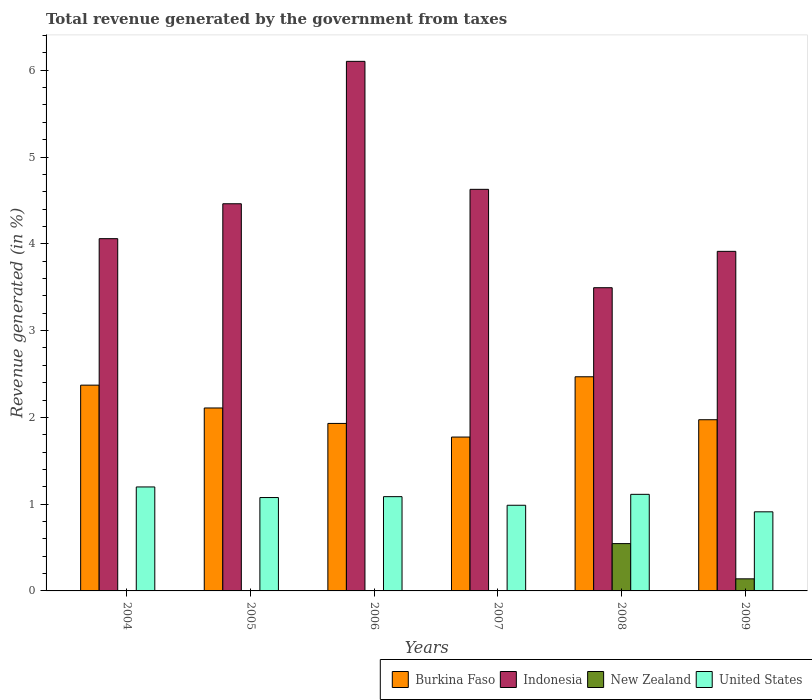How many groups of bars are there?
Your response must be concise. 6. Are the number of bars per tick equal to the number of legend labels?
Your answer should be very brief. Yes. How many bars are there on the 3rd tick from the left?
Offer a very short reply. 4. How many bars are there on the 2nd tick from the right?
Provide a succinct answer. 4. In how many cases, is the number of bars for a given year not equal to the number of legend labels?
Give a very brief answer. 0. What is the total revenue generated in United States in 2007?
Your response must be concise. 0.99. Across all years, what is the maximum total revenue generated in United States?
Make the answer very short. 1.2. Across all years, what is the minimum total revenue generated in Burkina Faso?
Offer a terse response. 1.77. In which year was the total revenue generated in Indonesia maximum?
Keep it short and to the point. 2006. In which year was the total revenue generated in Indonesia minimum?
Provide a short and direct response. 2008. What is the total total revenue generated in New Zealand in the graph?
Provide a short and direct response. 0.7. What is the difference between the total revenue generated in Indonesia in 2004 and that in 2005?
Your answer should be very brief. -0.4. What is the difference between the total revenue generated in United States in 2007 and the total revenue generated in Indonesia in 2006?
Offer a very short reply. -5.12. What is the average total revenue generated in New Zealand per year?
Make the answer very short. 0.12. In the year 2006, what is the difference between the total revenue generated in Burkina Faso and total revenue generated in New Zealand?
Offer a very short reply. 1.93. What is the ratio of the total revenue generated in United States in 2004 to that in 2006?
Make the answer very short. 1.1. Is the total revenue generated in Indonesia in 2004 less than that in 2008?
Offer a terse response. No. Is the difference between the total revenue generated in Burkina Faso in 2004 and 2006 greater than the difference between the total revenue generated in New Zealand in 2004 and 2006?
Make the answer very short. Yes. What is the difference between the highest and the second highest total revenue generated in Indonesia?
Make the answer very short. 1.47. What is the difference between the highest and the lowest total revenue generated in New Zealand?
Your response must be concise. 0.54. What does the 2nd bar from the right in 2008 represents?
Provide a succinct answer. New Zealand. Is it the case that in every year, the sum of the total revenue generated in Burkina Faso and total revenue generated in Indonesia is greater than the total revenue generated in New Zealand?
Offer a terse response. Yes. How many bars are there?
Offer a very short reply. 24. Are all the bars in the graph horizontal?
Make the answer very short. No. How many years are there in the graph?
Give a very brief answer. 6. What is the difference between two consecutive major ticks on the Y-axis?
Ensure brevity in your answer.  1. Does the graph contain any zero values?
Make the answer very short. No. How are the legend labels stacked?
Your response must be concise. Horizontal. What is the title of the graph?
Provide a succinct answer. Total revenue generated by the government from taxes. Does "Serbia" appear as one of the legend labels in the graph?
Give a very brief answer. No. What is the label or title of the Y-axis?
Your answer should be very brief. Revenue generated (in %). What is the Revenue generated (in %) in Burkina Faso in 2004?
Provide a short and direct response. 2.37. What is the Revenue generated (in %) in Indonesia in 2004?
Your answer should be very brief. 4.06. What is the Revenue generated (in %) of New Zealand in 2004?
Provide a short and direct response. 0. What is the Revenue generated (in %) of United States in 2004?
Keep it short and to the point. 1.2. What is the Revenue generated (in %) in Burkina Faso in 2005?
Make the answer very short. 2.11. What is the Revenue generated (in %) in Indonesia in 2005?
Offer a terse response. 4.46. What is the Revenue generated (in %) in New Zealand in 2005?
Make the answer very short. 0. What is the Revenue generated (in %) in United States in 2005?
Give a very brief answer. 1.08. What is the Revenue generated (in %) of Burkina Faso in 2006?
Make the answer very short. 1.93. What is the Revenue generated (in %) of Indonesia in 2006?
Offer a terse response. 6.1. What is the Revenue generated (in %) of New Zealand in 2006?
Offer a very short reply. 0. What is the Revenue generated (in %) in United States in 2006?
Provide a succinct answer. 1.09. What is the Revenue generated (in %) in Burkina Faso in 2007?
Provide a succinct answer. 1.77. What is the Revenue generated (in %) of Indonesia in 2007?
Provide a succinct answer. 4.63. What is the Revenue generated (in %) of New Zealand in 2007?
Keep it short and to the point. 0. What is the Revenue generated (in %) of United States in 2007?
Your answer should be compact. 0.99. What is the Revenue generated (in %) in Burkina Faso in 2008?
Your response must be concise. 2.47. What is the Revenue generated (in %) of Indonesia in 2008?
Provide a short and direct response. 3.49. What is the Revenue generated (in %) of New Zealand in 2008?
Ensure brevity in your answer.  0.55. What is the Revenue generated (in %) in United States in 2008?
Provide a succinct answer. 1.11. What is the Revenue generated (in %) in Burkina Faso in 2009?
Ensure brevity in your answer.  1.97. What is the Revenue generated (in %) in Indonesia in 2009?
Provide a short and direct response. 3.91. What is the Revenue generated (in %) in New Zealand in 2009?
Keep it short and to the point. 0.14. What is the Revenue generated (in %) in United States in 2009?
Offer a very short reply. 0.91. Across all years, what is the maximum Revenue generated (in %) of Burkina Faso?
Your response must be concise. 2.47. Across all years, what is the maximum Revenue generated (in %) in Indonesia?
Your answer should be compact. 6.1. Across all years, what is the maximum Revenue generated (in %) of New Zealand?
Provide a succinct answer. 0.55. Across all years, what is the maximum Revenue generated (in %) in United States?
Provide a succinct answer. 1.2. Across all years, what is the minimum Revenue generated (in %) of Burkina Faso?
Keep it short and to the point. 1.77. Across all years, what is the minimum Revenue generated (in %) of Indonesia?
Your answer should be compact. 3.49. Across all years, what is the minimum Revenue generated (in %) in New Zealand?
Your answer should be very brief. 0. Across all years, what is the minimum Revenue generated (in %) of United States?
Your answer should be compact. 0.91. What is the total Revenue generated (in %) in Burkina Faso in the graph?
Offer a very short reply. 12.62. What is the total Revenue generated (in %) of Indonesia in the graph?
Make the answer very short. 26.66. What is the total Revenue generated (in %) of New Zealand in the graph?
Offer a terse response. 0.7. What is the total Revenue generated (in %) in United States in the graph?
Make the answer very short. 6.37. What is the difference between the Revenue generated (in %) in Burkina Faso in 2004 and that in 2005?
Your response must be concise. 0.26. What is the difference between the Revenue generated (in %) of Indonesia in 2004 and that in 2005?
Provide a short and direct response. -0.4. What is the difference between the Revenue generated (in %) in New Zealand in 2004 and that in 2005?
Your answer should be very brief. 0. What is the difference between the Revenue generated (in %) of United States in 2004 and that in 2005?
Provide a succinct answer. 0.12. What is the difference between the Revenue generated (in %) in Burkina Faso in 2004 and that in 2006?
Your answer should be compact. 0.44. What is the difference between the Revenue generated (in %) in Indonesia in 2004 and that in 2006?
Provide a short and direct response. -2.04. What is the difference between the Revenue generated (in %) of New Zealand in 2004 and that in 2006?
Provide a short and direct response. -0. What is the difference between the Revenue generated (in %) of United States in 2004 and that in 2006?
Provide a short and direct response. 0.11. What is the difference between the Revenue generated (in %) of Burkina Faso in 2004 and that in 2007?
Provide a succinct answer. 0.6. What is the difference between the Revenue generated (in %) of Indonesia in 2004 and that in 2007?
Give a very brief answer. -0.57. What is the difference between the Revenue generated (in %) of New Zealand in 2004 and that in 2007?
Your response must be concise. 0. What is the difference between the Revenue generated (in %) of United States in 2004 and that in 2007?
Give a very brief answer. 0.21. What is the difference between the Revenue generated (in %) of Burkina Faso in 2004 and that in 2008?
Your response must be concise. -0.1. What is the difference between the Revenue generated (in %) of Indonesia in 2004 and that in 2008?
Your answer should be very brief. 0.57. What is the difference between the Revenue generated (in %) in New Zealand in 2004 and that in 2008?
Your answer should be very brief. -0.54. What is the difference between the Revenue generated (in %) of United States in 2004 and that in 2008?
Offer a terse response. 0.09. What is the difference between the Revenue generated (in %) of Burkina Faso in 2004 and that in 2009?
Provide a succinct answer. 0.4. What is the difference between the Revenue generated (in %) of Indonesia in 2004 and that in 2009?
Ensure brevity in your answer.  0.15. What is the difference between the Revenue generated (in %) in New Zealand in 2004 and that in 2009?
Provide a succinct answer. -0.13. What is the difference between the Revenue generated (in %) in United States in 2004 and that in 2009?
Give a very brief answer. 0.29. What is the difference between the Revenue generated (in %) of Burkina Faso in 2005 and that in 2006?
Provide a succinct answer. 0.18. What is the difference between the Revenue generated (in %) in Indonesia in 2005 and that in 2006?
Provide a short and direct response. -1.64. What is the difference between the Revenue generated (in %) of New Zealand in 2005 and that in 2006?
Offer a very short reply. -0. What is the difference between the Revenue generated (in %) in United States in 2005 and that in 2006?
Your answer should be compact. -0.01. What is the difference between the Revenue generated (in %) of Burkina Faso in 2005 and that in 2007?
Ensure brevity in your answer.  0.34. What is the difference between the Revenue generated (in %) of Indonesia in 2005 and that in 2007?
Keep it short and to the point. -0.17. What is the difference between the Revenue generated (in %) in New Zealand in 2005 and that in 2007?
Offer a terse response. 0. What is the difference between the Revenue generated (in %) of United States in 2005 and that in 2007?
Your answer should be compact. 0.09. What is the difference between the Revenue generated (in %) in Burkina Faso in 2005 and that in 2008?
Offer a very short reply. -0.36. What is the difference between the Revenue generated (in %) in Indonesia in 2005 and that in 2008?
Your answer should be compact. 0.97. What is the difference between the Revenue generated (in %) of New Zealand in 2005 and that in 2008?
Your answer should be very brief. -0.54. What is the difference between the Revenue generated (in %) in United States in 2005 and that in 2008?
Offer a very short reply. -0.04. What is the difference between the Revenue generated (in %) of Burkina Faso in 2005 and that in 2009?
Provide a succinct answer. 0.14. What is the difference between the Revenue generated (in %) of Indonesia in 2005 and that in 2009?
Offer a terse response. 0.55. What is the difference between the Revenue generated (in %) of New Zealand in 2005 and that in 2009?
Your answer should be compact. -0.14. What is the difference between the Revenue generated (in %) in United States in 2005 and that in 2009?
Provide a short and direct response. 0.16. What is the difference between the Revenue generated (in %) in Burkina Faso in 2006 and that in 2007?
Offer a terse response. 0.16. What is the difference between the Revenue generated (in %) of Indonesia in 2006 and that in 2007?
Your answer should be compact. 1.47. What is the difference between the Revenue generated (in %) in New Zealand in 2006 and that in 2007?
Offer a terse response. 0. What is the difference between the Revenue generated (in %) of United States in 2006 and that in 2007?
Offer a very short reply. 0.1. What is the difference between the Revenue generated (in %) in Burkina Faso in 2006 and that in 2008?
Ensure brevity in your answer.  -0.54. What is the difference between the Revenue generated (in %) in Indonesia in 2006 and that in 2008?
Make the answer very short. 2.61. What is the difference between the Revenue generated (in %) in New Zealand in 2006 and that in 2008?
Your response must be concise. -0.54. What is the difference between the Revenue generated (in %) of United States in 2006 and that in 2008?
Ensure brevity in your answer.  -0.03. What is the difference between the Revenue generated (in %) of Burkina Faso in 2006 and that in 2009?
Your response must be concise. -0.04. What is the difference between the Revenue generated (in %) in Indonesia in 2006 and that in 2009?
Your response must be concise. 2.19. What is the difference between the Revenue generated (in %) of New Zealand in 2006 and that in 2009?
Your answer should be very brief. -0.13. What is the difference between the Revenue generated (in %) of United States in 2006 and that in 2009?
Ensure brevity in your answer.  0.17. What is the difference between the Revenue generated (in %) in Burkina Faso in 2007 and that in 2008?
Offer a terse response. -0.69. What is the difference between the Revenue generated (in %) in Indonesia in 2007 and that in 2008?
Keep it short and to the point. 1.13. What is the difference between the Revenue generated (in %) of New Zealand in 2007 and that in 2008?
Offer a very short reply. -0.54. What is the difference between the Revenue generated (in %) in United States in 2007 and that in 2008?
Your answer should be very brief. -0.13. What is the difference between the Revenue generated (in %) in Burkina Faso in 2007 and that in 2009?
Keep it short and to the point. -0.2. What is the difference between the Revenue generated (in %) in Indonesia in 2007 and that in 2009?
Your answer should be very brief. 0.71. What is the difference between the Revenue generated (in %) of New Zealand in 2007 and that in 2009?
Ensure brevity in your answer.  -0.14. What is the difference between the Revenue generated (in %) in United States in 2007 and that in 2009?
Offer a terse response. 0.08. What is the difference between the Revenue generated (in %) in Burkina Faso in 2008 and that in 2009?
Your answer should be very brief. 0.49. What is the difference between the Revenue generated (in %) in Indonesia in 2008 and that in 2009?
Your answer should be compact. -0.42. What is the difference between the Revenue generated (in %) of New Zealand in 2008 and that in 2009?
Provide a succinct answer. 0.41. What is the difference between the Revenue generated (in %) of United States in 2008 and that in 2009?
Ensure brevity in your answer.  0.2. What is the difference between the Revenue generated (in %) in Burkina Faso in 2004 and the Revenue generated (in %) in Indonesia in 2005?
Give a very brief answer. -2.09. What is the difference between the Revenue generated (in %) in Burkina Faso in 2004 and the Revenue generated (in %) in New Zealand in 2005?
Your answer should be compact. 2.37. What is the difference between the Revenue generated (in %) of Burkina Faso in 2004 and the Revenue generated (in %) of United States in 2005?
Your response must be concise. 1.29. What is the difference between the Revenue generated (in %) of Indonesia in 2004 and the Revenue generated (in %) of New Zealand in 2005?
Ensure brevity in your answer.  4.06. What is the difference between the Revenue generated (in %) of Indonesia in 2004 and the Revenue generated (in %) of United States in 2005?
Ensure brevity in your answer.  2.98. What is the difference between the Revenue generated (in %) of New Zealand in 2004 and the Revenue generated (in %) of United States in 2005?
Your response must be concise. -1.07. What is the difference between the Revenue generated (in %) of Burkina Faso in 2004 and the Revenue generated (in %) of Indonesia in 2006?
Provide a succinct answer. -3.73. What is the difference between the Revenue generated (in %) in Burkina Faso in 2004 and the Revenue generated (in %) in New Zealand in 2006?
Make the answer very short. 2.37. What is the difference between the Revenue generated (in %) in Burkina Faso in 2004 and the Revenue generated (in %) in United States in 2006?
Offer a terse response. 1.28. What is the difference between the Revenue generated (in %) of Indonesia in 2004 and the Revenue generated (in %) of New Zealand in 2006?
Your answer should be very brief. 4.05. What is the difference between the Revenue generated (in %) of Indonesia in 2004 and the Revenue generated (in %) of United States in 2006?
Your answer should be compact. 2.97. What is the difference between the Revenue generated (in %) of New Zealand in 2004 and the Revenue generated (in %) of United States in 2006?
Offer a terse response. -1.08. What is the difference between the Revenue generated (in %) in Burkina Faso in 2004 and the Revenue generated (in %) in Indonesia in 2007?
Provide a succinct answer. -2.26. What is the difference between the Revenue generated (in %) of Burkina Faso in 2004 and the Revenue generated (in %) of New Zealand in 2007?
Ensure brevity in your answer.  2.37. What is the difference between the Revenue generated (in %) of Burkina Faso in 2004 and the Revenue generated (in %) of United States in 2007?
Provide a short and direct response. 1.38. What is the difference between the Revenue generated (in %) of Indonesia in 2004 and the Revenue generated (in %) of New Zealand in 2007?
Provide a short and direct response. 4.06. What is the difference between the Revenue generated (in %) of Indonesia in 2004 and the Revenue generated (in %) of United States in 2007?
Offer a very short reply. 3.07. What is the difference between the Revenue generated (in %) in New Zealand in 2004 and the Revenue generated (in %) in United States in 2007?
Provide a succinct answer. -0.98. What is the difference between the Revenue generated (in %) in Burkina Faso in 2004 and the Revenue generated (in %) in Indonesia in 2008?
Your answer should be compact. -1.12. What is the difference between the Revenue generated (in %) of Burkina Faso in 2004 and the Revenue generated (in %) of New Zealand in 2008?
Offer a very short reply. 1.83. What is the difference between the Revenue generated (in %) of Burkina Faso in 2004 and the Revenue generated (in %) of United States in 2008?
Make the answer very short. 1.26. What is the difference between the Revenue generated (in %) of Indonesia in 2004 and the Revenue generated (in %) of New Zealand in 2008?
Your response must be concise. 3.51. What is the difference between the Revenue generated (in %) in Indonesia in 2004 and the Revenue generated (in %) in United States in 2008?
Ensure brevity in your answer.  2.95. What is the difference between the Revenue generated (in %) of New Zealand in 2004 and the Revenue generated (in %) of United States in 2008?
Offer a terse response. -1.11. What is the difference between the Revenue generated (in %) in Burkina Faso in 2004 and the Revenue generated (in %) in Indonesia in 2009?
Give a very brief answer. -1.54. What is the difference between the Revenue generated (in %) in Burkina Faso in 2004 and the Revenue generated (in %) in New Zealand in 2009?
Provide a short and direct response. 2.23. What is the difference between the Revenue generated (in %) of Burkina Faso in 2004 and the Revenue generated (in %) of United States in 2009?
Offer a terse response. 1.46. What is the difference between the Revenue generated (in %) in Indonesia in 2004 and the Revenue generated (in %) in New Zealand in 2009?
Provide a succinct answer. 3.92. What is the difference between the Revenue generated (in %) in Indonesia in 2004 and the Revenue generated (in %) in United States in 2009?
Ensure brevity in your answer.  3.15. What is the difference between the Revenue generated (in %) of New Zealand in 2004 and the Revenue generated (in %) of United States in 2009?
Your response must be concise. -0.91. What is the difference between the Revenue generated (in %) in Burkina Faso in 2005 and the Revenue generated (in %) in Indonesia in 2006?
Provide a short and direct response. -3.99. What is the difference between the Revenue generated (in %) of Burkina Faso in 2005 and the Revenue generated (in %) of New Zealand in 2006?
Your answer should be very brief. 2.1. What is the difference between the Revenue generated (in %) in Burkina Faso in 2005 and the Revenue generated (in %) in United States in 2006?
Ensure brevity in your answer.  1.02. What is the difference between the Revenue generated (in %) in Indonesia in 2005 and the Revenue generated (in %) in New Zealand in 2006?
Your answer should be very brief. 4.46. What is the difference between the Revenue generated (in %) of Indonesia in 2005 and the Revenue generated (in %) of United States in 2006?
Keep it short and to the point. 3.38. What is the difference between the Revenue generated (in %) of New Zealand in 2005 and the Revenue generated (in %) of United States in 2006?
Offer a terse response. -1.08. What is the difference between the Revenue generated (in %) of Burkina Faso in 2005 and the Revenue generated (in %) of Indonesia in 2007?
Keep it short and to the point. -2.52. What is the difference between the Revenue generated (in %) in Burkina Faso in 2005 and the Revenue generated (in %) in New Zealand in 2007?
Provide a short and direct response. 2.11. What is the difference between the Revenue generated (in %) of Burkina Faso in 2005 and the Revenue generated (in %) of United States in 2007?
Offer a very short reply. 1.12. What is the difference between the Revenue generated (in %) of Indonesia in 2005 and the Revenue generated (in %) of New Zealand in 2007?
Keep it short and to the point. 4.46. What is the difference between the Revenue generated (in %) in Indonesia in 2005 and the Revenue generated (in %) in United States in 2007?
Provide a short and direct response. 3.47. What is the difference between the Revenue generated (in %) in New Zealand in 2005 and the Revenue generated (in %) in United States in 2007?
Provide a short and direct response. -0.98. What is the difference between the Revenue generated (in %) in Burkina Faso in 2005 and the Revenue generated (in %) in Indonesia in 2008?
Provide a succinct answer. -1.39. What is the difference between the Revenue generated (in %) in Burkina Faso in 2005 and the Revenue generated (in %) in New Zealand in 2008?
Your answer should be very brief. 1.56. What is the difference between the Revenue generated (in %) in Burkina Faso in 2005 and the Revenue generated (in %) in United States in 2008?
Your answer should be compact. 1. What is the difference between the Revenue generated (in %) in Indonesia in 2005 and the Revenue generated (in %) in New Zealand in 2008?
Offer a very short reply. 3.92. What is the difference between the Revenue generated (in %) in Indonesia in 2005 and the Revenue generated (in %) in United States in 2008?
Offer a terse response. 3.35. What is the difference between the Revenue generated (in %) of New Zealand in 2005 and the Revenue generated (in %) of United States in 2008?
Your answer should be compact. -1.11. What is the difference between the Revenue generated (in %) of Burkina Faso in 2005 and the Revenue generated (in %) of Indonesia in 2009?
Offer a terse response. -1.8. What is the difference between the Revenue generated (in %) of Burkina Faso in 2005 and the Revenue generated (in %) of New Zealand in 2009?
Make the answer very short. 1.97. What is the difference between the Revenue generated (in %) in Burkina Faso in 2005 and the Revenue generated (in %) in United States in 2009?
Offer a very short reply. 1.2. What is the difference between the Revenue generated (in %) in Indonesia in 2005 and the Revenue generated (in %) in New Zealand in 2009?
Keep it short and to the point. 4.32. What is the difference between the Revenue generated (in %) of Indonesia in 2005 and the Revenue generated (in %) of United States in 2009?
Provide a succinct answer. 3.55. What is the difference between the Revenue generated (in %) in New Zealand in 2005 and the Revenue generated (in %) in United States in 2009?
Provide a succinct answer. -0.91. What is the difference between the Revenue generated (in %) of Burkina Faso in 2006 and the Revenue generated (in %) of Indonesia in 2007?
Your response must be concise. -2.7. What is the difference between the Revenue generated (in %) in Burkina Faso in 2006 and the Revenue generated (in %) in New Zealand in 2007?
Make the answer very short. 1.93. What is the difference between the Revenue generated (in %) in Burkina Faso in 2006 and the Revenue generated (in %) in United States in 2007?
Give a very brief answer. 0.94. What is the difference between the Revenue generated (in %) in Indonesia in 2006 and the Revenue generated (in %) in New Zealand in 2007?
Offer a very short reply. 6.1. What is the difference between the Revenue generated (in %) in Indonesia in 2006 and the Revenue generated (in %) in United States in 2007?
Offer a very short reply. 5.12. What is the difference between the Revenue generated (in %) of New Zealand in 2006 and the Revenue generated (in %) of United States in 2007?
Give a very brief answer. -0.98. What is the difference between the Revenue generated (in %) of Burkina Faso in 2006 and the Revenue generated (in %) of Indonesia in 2008?
Offer a very short reply. -1.56. What is the difference between the Revenue generated (in %) in Burkina Faso in 2006 and the Revenue generated (in %) in New Zealand in 2008?
Your answer should be compact. 1.38. What is the difference between the Revenue generated (in %) in Burkina Faso in 2006 and the Revenue generated (in %) in United States in 2008?
Your answer should be very brief. 0.82. What is the difference between the Revenue generated (in %) of Indonesia in 2006 and the Revenue generated (in %) of New Zealand in 2008?
Provide a short and direct response. 5.56. What is the difference between the Revenue generated (in %) in Indonesia in 2006 and the Revenue generated (in %) in United States in 2008?
Offer a very short reply. 4.99. What is the difference between the Revenue generated (in %) in New Zealand in 2006 and the Revenue generated (in %) in United States in 2008?
Your answer should be compact. -1.11. What is the difference between the Revenue generated (in %) in Burkina Faso in 2006 and the Revenue generated (in %) in Indonesia in 2009?
Give a very brief answer. -1.98. What is the difference between the Revenue generated (in %) in Burkina Faso in 2006 and the Revenue generated (in %) in New Zealand in 2009?
Offer a terse response. 1.79. What is the difference between the Revenue generated (in %) of Burkina Faso in 2006 and the Revenue generated (in %) of United States in 2009?
Make the answer very short. 1.02. What is the difference between the Revenue generated (in %) in Indonesia in 2006 and the Revenue generated (in %) in New Zealand in 2009?
Provide a short and direct response. 5.96. What is the difference between the Revenue generated (in %) in Indonesia in 2006 and the Revenue generated (in %) in United States in 2009?
Your answer should be very brief. 5.19. What is the difference between the Revenue generated (in %) in New Zealand in 2006 and the Revenue generated (in %) in United States in 2009?
Keep it short and to the point. -0.91. What is the difference between the Revenue generated (in %) of Burkina Faso in 2007 and the Revenue generated (in %) of Indonesia in 2008?
Offer a very short reply. -1.72. What is the difference between the Revenue generated (in %) of Burkina Faso in 2007 and the Revenue generated (in %) of New Zealand in 2008?
Your response must be concise. 1.23. What is the difference between the Revenue generated (in %) of Burkina Faso in 2007 and the Revenue generated (in %) of United States in 2008?
Give a very brief answer. 0.66. What is the difference between the Revenue generated (in %) of Indonesia in 2007 and the Revenue generated (in %) of New Zealand in 2008?
Your response must be concise. 4.08. What is the difference between the Revenue generated (in %) in Indonesia in 2007 and the Revenue generated (in %) in United States in 2008?
Ensure brevity in your answer.  3.51. What is the difference between the Revenue generated (in %) of New Zealand in 2007 and the Revenue generated (in %) of United States in 2008?
Offer a very short reply. -1.11. What is the difference between the Revenue generated (in %) of Burkina Faso in 2007 and the Revenue generated (in %) of Indonesia in 2009?
Offer a terse response. -2.14. What is the difference between the Revenue generated (in %) in Burkina Faso in 2007 and the Revenue generated (in %) in New Zealand in 2009?
Ensure brevity in your answer.  1.63. What is the difference between the Revenue generated (in %) in Burkina Faso in 2007 and the Revenue generated (in %) in United States in 2009?
Provide a succinct answer. 0.86. What is the difference between the Revenue generated (in %) of Indonesia in 2007 and the Revenue generated (in %) of New Zealand in 2009?
Your response must be concise. 4.49. What is the difference between the Revenue generated (in %) of Indonesia in 2007 and the Revenue generated (in %) of United States in 2009?
Provide a short and direct response. 3.72. What is the difference between the Revenue generated (in %) of New Zealand in 2007 and the Revenue generated (in %) of United States in 2009?
Your response must be concise. -0.91. What is the difference between the Revenue generated (in %) in Burkina Faso in 2008 and the Revenue generated (in %) in Indonesia in 2009?
Offer a very short reply. -1.45. What is the difference between the Revenue generated (in %) in Burkina Faso in 2008 and the Revenue generated (in %) in New Zealand in 2009?
Your answer should be compact. 2.33. What is the difference between the Revenue generated (in %) in Burkina Faso in 2008 and the Revenue generated (in %) in United States in 2009?
Ensure brevity in your answer.  1.56. What is the difference between the Revenue generated (in %) in Indonesia in 2008 and the Revenue generated (in %) in New Zealand in 2009?
Offer a terse response. 3.35. What is the difference between the Revenue generated (in %) of Indonesia in 2008 and the Revenue generated (in %) of United States in 2009?
Provide a succinct answer. 2.58. What is the difference between the Revenue generated (in %) of New Zealand in 2008 and the Revenue generated (in %) of United States in 2009?
Your response must be concise. -0.37. What is the average Revenue generated (in %) in Burkina Faso per year?
Keep it short and to the point. 2.1. What is the average Revenue generated (in %) in Indonesia per year?
Make the answer very short. 4.44. What is the average Revenue generated (in %) of New Zealand per year?
Give a very brief answer. 0.12. What is the average Revenue generated (in %) of United States per year?
Your answer should be very brief. 1.06. In the year 2004, what is the difference between the Revenue generated (in %) in Burkina Faso and Revenue generated (in %) in Indonesia?
Provide a succinct answer. -1.69. In the year 2004, what is the difference between the Revenue generated (in %) in Burkina Faso and Revenue generated (in %) in New Zealand?
Provide a succinct answer. 2.37. In the year 2004, what is the difference between the Revenue generated (in %) of Burkina Faso and Revenue generated (in %) of United States?
Provide a short and direct response. 1.17. In the year 2004, what is the difference between the Revenue generated (in %) of Indonesia and Revenue generated (in %) of New Zealand?
Ensure brevity in your answer.  4.05. In the year 2004, what is the difference between the Revenue generated (in %) in Indonesia and Revenue generated (in %) in United States?
Keep it short and to the point. 2.86. In the year 2004, what is the difference between the Revenue generated (in %) in New Zealand and Revenue generated (in %) in United States?
Offer a terse response. -1.19. In the year 2005, what is the difference between the Revenue generated (in %) of Burkina Faso and Revenue generated (in %) of Indonesia?
Offer a terse response. -2.35. In the year 2005, what is the difference between the Revenue generated (in %) of Burkina Faso and Revenue generated (in %) of New Zealand?
Your response must be concise. 2.1. In the year 2005, what is the difference between the Revenue generated (in %) in Burkina Faso and Revenue generated (in %) in United States?
Your answer should be compact. 1.03. In the year 2005, what is the difference between the Revenue generated (in %) of Indonesia and Revenue generated (in %) of New Zealand?
Give a very brief answer. 4.46. In the year 2005, what is the difference between the Revenue generated (in %) of Indonesia and Revenue generated (in %) of United States?
Provide a short and direct response. 3.39. In the year 2005, what is the difference between the Revenue generated (in %) of New Zealand and Revenue generated (in %) of United States?
Your response must be concise. -1.07. In the year 2006, what is the difference between the Revenue generated (in %) of Burkina Faso and Revenue generated (in %) of Indonesia?
Give a very brief answer. -4.17. In the year 2006, what is the difference between the Revenue generated (in %) of Burkina Faso and Revenue generated (in %) of New Zealand?
Ensure brevity in your answer.  1.93. In the year 2006, what is the difference between the Revenue generated (in %) in Burkina Faso and Revenue generated (in %) in United States?
Keep it short and to the point. 0.84. In the year 2006, what is the difference between the Revenue generated (in %) in Indonesia and Revenue generated (in %) in New Zealand?
Ensure brevity in your answer.  6.1. In the year 2006, what is the difference between the Revenue generated (in %) of Indonesia and Revenue generated (in %) of United States?
Ensure brevity in your answer.  5.02. In the year 2006, what is the difference between the Revenue generated (in %) of New Zealand and Revenue generated (in %) of United States?
Provide a succinct answer. -1.08. In the year 2007, what is the difference between the Revenue generated (in %) in Burkina Faso and Revenue generated (in %) in Indonesia?
Offer a terse response. -2.85. In the year 2007, what is the difference between the Revenue generated (in %) in Burkina Faso and Revenue generated (in %) in New Zealand?
Give a very brief answer. 1.77. In the year 2007, what is the difference between the Revenue generated (in %) in Burkina Faso and Revenue generated (in %) in United States?
Provide a short and direct response. 0.79. In the year 2007, what is the difference between the Revenue generated (in %) of Indonesia and Revenue generated (in %) of New Zealand?
Give a very brief answer. 4.62. In the year 2007, what is the difference between the Revenue generated (in %) of Indonesia and Revenue generated (in %) of United States?
Give a very brief answer. 3.64. In the year 2007, what is the difference between the Revenue generated (in %) in New Zealand and Revenue generated (in %) in United States?
Offer a very short reply. -0.98. In the year 2008, what is the difference between the Revenue generated (in %) of Burkina Faso and Revenue generated (in %) of Indonesia?
Give a very brief answer. -1.03. In the year 2008, what is the difference between the Revenue generated (in %) in Burkina Faso and Revenue generated (in %) in New Zealand?
Your response must be concise. 1.92. In the year 2008, what is the difference between the Revenue generated (in %) in Burkina Faso and Revenue generated (in %) in United States?
Ensure brevity in your answer.  1.35. In the year 2008, what is the difference between the Revenue generated (in %) in Indonesia and Revenue generated (in %) in New Zealand?
Give a very brief answer. 2.95. In the year 2008, what is the difference between the Revenue generated (in %) in Indonesia and Revenue generated (in %) in United States?
Provide a succinct answer. 2.38. In the year 2008, what is the difference between the Revenue generated (in %) in New Zealand and Revenue generated (in %) in United States?
Provide a succinct answer. -0.57. In the year 2009, what is the difference between the Revenue generated (in %) of Burkina Faso and Revenue generated (in %) of Indonesia?
Offer a terse response. -1.94. In the year 2009, what is the difference between the Revenue generated (in %) in Burkina Faso and Revenue generated (in %) in New Zealand?
Your answer should be compact. 1.83. In the year 2009, what is the difference between the Revenue generated (in %) of Burkina Faso and Revenue generated (in %) of United States?
Give a very brief answer. 1.06. In the year 2009, what is the difference between the Revenue generated (in %) in Indonesia and Revenue generated (in %) in New Zealand?
Your answer should be compact. 3.77. In the year 2009, what is the difference between the Revenue generated (in %) of Indonesia and Revenue generated (in %) of United States?
Make the answer very short. 3. In the year 2009, what is the difference between the Revenue generated (in %) of New Zealand and Revenue generated (in %) of United States?
Offer a terse response. -0.77. What is the ratio of the Revenue generated (in %) in Burkina Faso in 2004 to that in 2005?
Provide a short and direct response. 1.12. What is the ratio of the Revenue generated (in %) in Indonesia in 2004 to that in 2005?
Your response must be concise. 0.91. What is the ratio of the Revenue generated (in %) of New Zealand in 2004 to that in 2005?
Your answer should be very brief. 1.11. What is the ratio of the Revenue generated (in %) in United States in 2004 to that in 2005?
Your answer should be very brief. 1.11. What is the ratio of the Revenue generated (in %) of Burkina Faso in 2004 to that in 2006?
Keep it short and to the point. 1.23. What is the ratio of the Revenue generated (in %) of Indonesia in 2004 to that in 2006?
Offer a very short reply. 0.67. What is the ratio of the Revenue generated (in %) in New Zealand in 2004 to that in 2006?
Provide a short and direct response. 0.93. What is the ratio of the Revenue generated (in %) of United States in 2004 to that in 2006?
Provide a succinct answer. 1.1. What is the ratio of the Revenue generated (in %) in Burkina Faso in 2004 to that in 2007?
Offer a very short reply. 1.34. What is the ratio of the Revenue generated (in %) in Indonesia in 2004 to that in 2007?
Offer a terse response. 0.88. What is the ratio of the Revenue generated (in %) of New Zealand in 2004 to that in 2007?
Give a very brief answer. 1.45. What is the ratio of the Revenue generated (in %) in United States in 2004 to that in 2007?
Your answer should be very brief. 1.21. What is the ratio of the Revenue generated (in %) of Burkina Faso in 2004 to that in 2008?
Give a very brief answer. 0.96. What is the ratio of the Revenue generated (in %) in Indonesia in 2004 to that in 2008?
Your response must be concise. 1.16. What is the ratio of the Revenue generated (in %) in New Zealand in 2004 to that in 2008?
Offer a terse response. 0.01. What is the ratio of the Revenue generated (in %) of United States in 2004 to that in 2008?
Your response must be concise. 1.08. What is the ratio of the Revenue generated (in %) in Burkina Faso in 2004 to that in 2009?
Provide a short and direct response. 1.2. What is the ratio of the Revenue generated (in %) in Indonesia in 2004 to that in 2009?
Offer a terse response. 1.04. What is the ratio of the Revenue generated (in %) of New Zealand in 2004 to that in 2009?
Your answer should be very brief. 0.03. What is the ratio of the Revenue generated (in %) of United States in 2004 to that in 2009?
Your answer should be very brief. 1.31. What is the ratio of the Revenue generated (in %) of Burkina Faso in 2005 to that in 2006?
Your answer should be very brief. 1.09. What is the ratio of the Revenue generated (in %) of Indonesia in 2005 to that in 2006?
Give a very brief answer. 0.73. What is the ratio of the Revenue generated (in %) of New Zealand in 2005 to that in 2006?
Provide a succinct answer. 0.84. What is the ratio of the Revenue generated (in %) in Burkina Faso in 2005 to that in 2007?
Give a very brief answer. 1.19. What is the ratio of the Revenue generated (in %) in Indonesia in 2005 to that in 2007?
Give a very brief answer. 0.96. What is the ratio of the Revenue generated (in %) of New Zealand in 2005 to that in 2007?
Give a very brief answer. 1.3. What is the ratio of the Revenue generated (in %) in United States in 2005 to that in 2007?
Give a very brief answer. 1.09. What is the ratio of the Revenue generated (in %) in Burkina Faso in 2005 to that in 2008?
Keep it short and to the point. 0.85. What is the ratio of the Revenue generated (in %) in Indonesia in 2005 to that in 2008?
Your response must be concise. 1.28. What is the ratio of the Revenue generated (in %) in New Zealand in 2005 to that in 2008?
Give a very brief answer. 0.01. What is the ratio of the Revenue generated (in %) in United States in 2005 to that in 2008?
Offer a very short reply. 0.97. What is the ratio of the Revenue generated (in %) in Burkina Faso in 2005 to that in 2009?
Offer a very short reply. 1.07. What is the ratio of the Revenue generated (in %) in Indonesia in 2005 to that in 2009?
Provide a short and direct response. 1.14. What is the ratio of the Revenue generated (in %) in New Zealand in 2005 to that in 2009?
Give a very brief answer. 0.03. What is the ratio of the Revenue generated (in %) of United States in 2005 to that in 2009?
Ensure brevity in your answer.  1.18. What is the ratio of the Revenue generated (in %) in Burkina Faso in 2006 to that in 2007?
Provide a short and direct response. 1.09. What is the ratio of the Revenue generated (in %) in Indonesia in 2006 to that in 2007?
Make the answer very short. 1.32. What is the ratio of the Revenue generated (in %) in New Zealand in 2006 to that in 2007?
Keep it short and to the point. 1.55. What is the ratio of the Revenue generated (in %) in United States in 2006 to that in 2007?
Your answer should be very brief. 1.1. What is the ratio of the Revenue generated (in %) in Burkina Faso in 2006 to that in 2008?
Give a very brief answer. 0.78. What is the ratio of the Revenue generated (in %) in Indonesia in 2006 to that in 2008?
Keep it short and to the point. 1.75. What is the ratio of the Revenue generated (in %) in New Zealand in 2006 to that in 2008?
Your answer should be very brief. 0.01. What is the ratio of the Revenue generated (in %) in United States in 2006 to that in 2008?
Keep it short and to the point. 0.98. What is the ratio of the Revenue generated (in %) of Burkina Faso in 2006 to that in 2009?
Your answer should be very brief. 0.98. What is the ratio of the Revenue generated (in %) in Indonesia in 2006 to that in 2009?
Your answer should be very brief. 1.56. What is the ratio of the Revenue generated (in %) in New Zealand in 2006 to that in 2009?
Keep it short and to the point. 0.03. What is the ratio of the Revenue generated (in %) of United States in 2006 to that in 2009?
Keep it short and to the point. 1.19. What is the ratio of the Revenue generated (in %) of Burkina Faso in 2007 to that in 2008?
Ensure brevity in your answer.  0.72. What is the ratio of the Revenue generated (in %) in Indonesia in 2007 to that in 2008?
Give a very brief answer. 1.32. What is the ratio of the Revenue generated (in %) in New Zealand in 2007 to that in 2008?
Offer a very short reply. 0.01. What is the ratio of the Revenue generated (in %) of United States in 2007 to that in 2008?
Provide a succinct answer. 0.89. What is the ratio of the Revenue generated (in %) of Burkina Faso in 2007 to that in 2009?
Provide a short and direct response. 0.9. What is the ratio of the Revenue generated (in %) in Indonesia in 2007 to that in 2009?
Offer a very short reply. 1.18. What is the ratio of the Revenue generated (in %) of New Zealand in 2007 to that in 2009?
Your answer should be compact. 0.02. What is the ratio of the Revenue generated (in %) in United States in 2007 to that in 2009?
Keep it short and to the point. 1.08. What is the ratio of the Revenue generated (in %) in Burkina Faso in 2008 to that in 2009?
Ensure brevity in your answer.  1.25. What is the ratio of the Revenue generated (in %) in Indonesia in 2008 to that in 2009?
Provide a succinct answer. 0.89. What is the ratio of the Revenue generated (in %) of New Zealand in 2008 to that in 2009?
Offer a terse response. 3.91. What is the ratio of the Revenue generated (in %) of United States in 2008 to that in 2009?
Your answer should be compact. 1.22. What is the difference between the highest and the second highest Revenue generated (in %) of Burkina Faso?
Give a very brief answer. 0.1. What is the difference between the highest and the second highest Revenue generated (in %) in Indonesia?
Offer a very short reply. 1.47. What is the difference between the highest and the second highest Revenue generated (in %) of New Zealand?
Offer a terse response. 0.41. What is the difference between the highest and the second highest Revenue generated (in %) in United States?
Give a very brief answer. 0.09. What is the difference between the highest and the lowest Revenue generated (in %) in Burkina Faso?
Ensure brevity in your answer.  0.69. What is the difference between the highest and the lowest Revenue generated (in %) of Indonesia?
Offer a very short reply. 2.61. What is the difference between the highest and the lowest Revenue generated (in %) in New Zealand?
Your response must be concise. 0.54. What is the difference between the highest and the lowest Revenue generated (in %) in United States?
Offer a terse response. 0.29. 